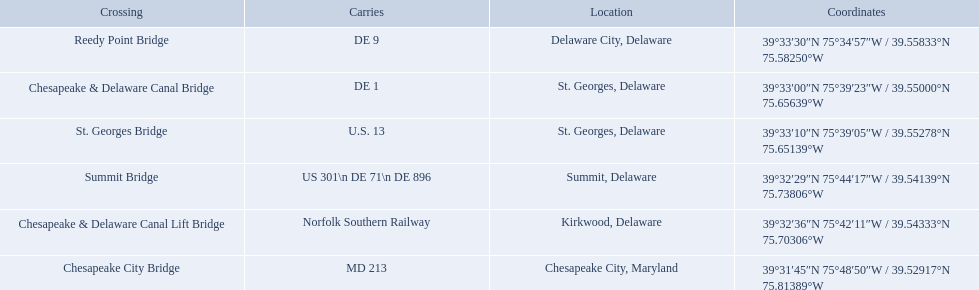Which bridges are in delaware? Summit Bridge, Chesapeake & Delaware Canal Lift Bridge, Chesapeake & Delaware Canal Bridge, St. Georges Bridge, Reedy Point Bridge. Which delaware bridge carries de 9? Reedy Point Bridge. Which are the bridges? Chesapeake City Bridge, Summit Bridge, Chesapeake & Delaware Canal Lift Bridge, Chesapeake & Delaware Canal Bridge, St. Georges Bridge, Reedy Point Bridge. Which are in delaware? Summit Bridge, Chesapeake & Delaware Canal Lift Bridge, Chesapeake & Delaware Canal Bridge, St. Georges Bridge, Reedy Point Bridge. Of these, which carries de 9? Reedy Point Bridge. 